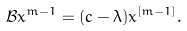<formula> <loc_0><loc_0><loc_500><loc_500>\mathcal { B } x ^ { m - 1 } = ( c - \lambda ) x ^ { [ m - 1 ] } .</formula> 